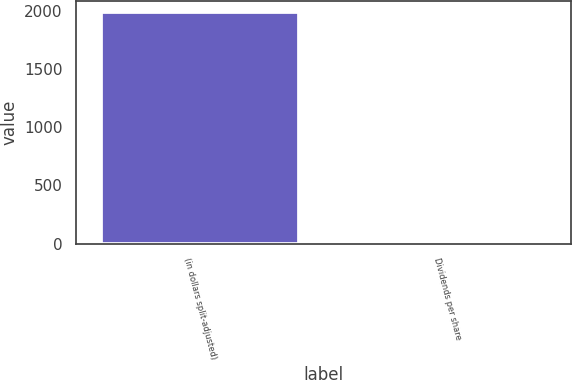Convert chart. <chart><loc_0><loc_0><loc_500><loc_500><bar_chart><fcel>(in dollars split-adjusted)<fcel>Dividends per share<nl><fcel>1987<fcel>0.17<nl></chart> 